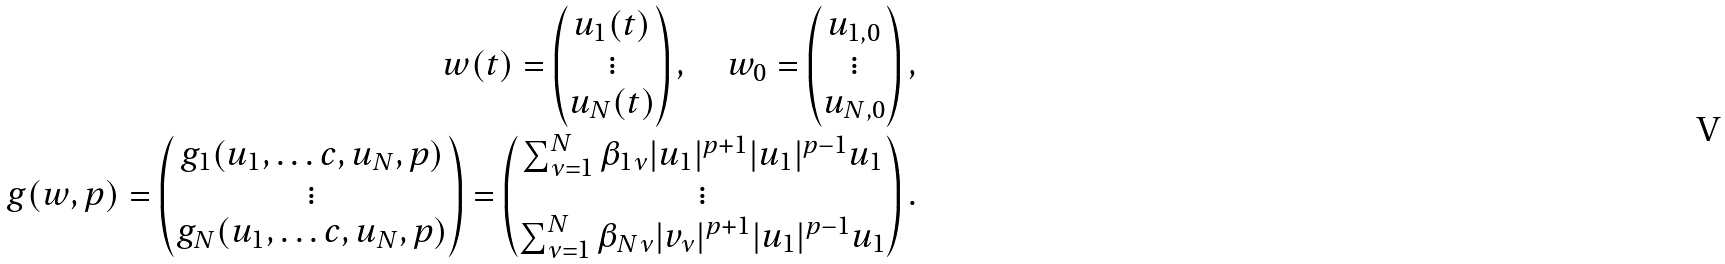<formula> <loc_0><loc_0><loc_500><loc_500>w ( t ) = \begin{pmatrix} u _ { 1 } ( t ) \\ \vdots \\ u _ { N } ( t ) \end{pmatrix} , \quad w _ { 0 } = \begin{pmatrix} u _ { 1 , 0 } \\ \vdots \\ u _ { N , 0 } \end{pmatrix} , \\ g ( w , p ) = \begin{pmatrix} g _ { 1 } ( u _ { 1 } , \dots c , u _ { N } , p ) \\ \vdots \\ g _ { N } ( u _ { 1 } , \dots c , u _ { N } , p ) \end{pmatrix} = \begin{pmatrix} \sum ^ { N } _ { \nu = 1 } \beta _ { 1 \nu } | u _ { 1 } | ^ { p + 1 } | u _ { 1 } | ^ { p - 1 } u _ { 1 } \\ \vdots \\ \sum ^ { N } _ { \nu = 1 } \beta _ { N \nu } | v _ { \nu } | ^ { p + 1 } | u _ { 1 } | ^ { p - 1 } u _ { 1 } \end{pmatrix} .</formula> 